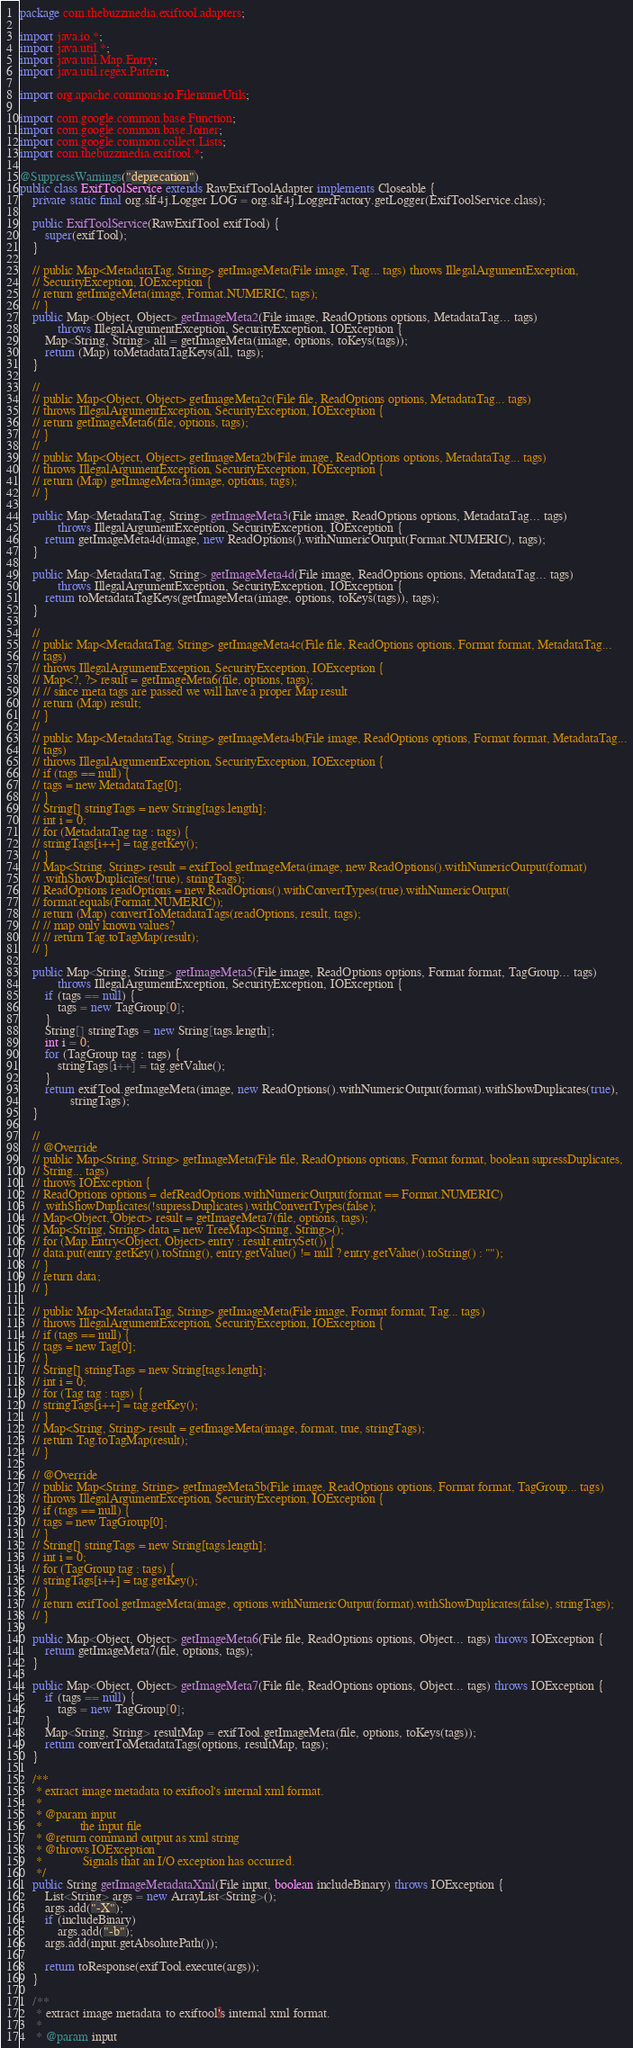<code> <loc_0><loc_0><loc_500><loc_500><_Java_>package com.thebuzzmedia.exiftool.adapters;

import java.io.*;
import java.util.*;
import java.util.Map.Entry;
import java.util.regex.Pattern;

import org.apache.commons.io.FilenameUtils;

import com.google.common.base.Function;
import com.google.common.base.Joiner;
import com.google.common.collect.Lists;
import com.thebuzzmedia.exiftool.*;

@SuppressWarnings("deprecation")
public class ExifToolService extends RawExifToolAdapter implements Closeable {
	private static final org.slf4j.Logger LOG = org.slf4j.LoggerFactory.getLogger(ExifToolService.class);

	public ExifToolService(RawExifTool exifTool) {
		super(exifTool);
	}

	// public Map<MetadataTag, String> getImageMeta(File image, Tag... tags) throws IllegalArgumentException,
	// SecurityException, IOException {
	// return getImageMeta(image, Format.NUMERIC, tags);
	// }
	public Map<Object, Object> getImageMeta2(File image, ReadOptions options, MetadataTag... tags)
			throws IllegalArgumentException, SecurityException, IOException {
		Map<String, String> all = getImageMeta(image, options, toKeys(tags));
		return (Map) toMetadataTagKeys(all, tags);
	}

	//
	// public Map<Object, Object> getImageMeta2c(File file, ReadOptions options, MetadataTag... tags)
	// throws IllegalArgumentException, SecurityException, IOException {
	// return getImageMeta6(file, options, tags);
	// }
	//
	// public Map<Object, Object> getImageMeta2b(File image, ReadOptions options, MetadataTag... tags)
	// throws IllegalArgumentException, SecurityException, IOException {
	// return (Map) getImageMeta3(image, options, tags);
	// }

	public Map<MetadataTag, String> getImageMeta3(File image, ReadOptions options, MetadataTag... tags)
			throws IllegalArgumentException, SecurityException, IOException {
		return getImageMeta4d(image, new ReadOptions().withNumericOutput(Format.NUMERIC), tags);
	}

	public Map<MetadataTag, String> getImageMeta4d(File image, ReadOptions options, MetadataTag... tags)
			throws IllegalArgumentException, SecurityException, IOException {
		return toMetadataTagKeys(getImageMeta(image, options, toKeys(tags)), tags);
	}

	//
	// public Map<MetadataTag, String> getImageMeta4c(File file, ReadOptions options, Format format, MetadataTag...
	// tags)
	// throws IllegalArgumentException, SecurityException, IOException {
	// Map<?, ?> result = getImageMeta6(file, options, tags);
	// // since meta tags are passed we will have a proper Map result
	// return (Map) result;
	// }
	//
	// public Map<MetadataTag, String> getImageMeta4b(File image, ReadOptions options, Format format, MetadataTag...
	// tags)
	// throws IllegalArgumentException, SecurityException, IOException {
	// if (tags == null) {
	// tags = new MetadataTag[0];
	// }
	// String[] stringTags = new String[tags.length];
	// int i = 0;
	// for (MetadataTag tag : tags) {
	// stringTags[i++] = tag.getKey();
	// }
	// Map<String, String> result = exifTool.getImageMeta(image, new ReadOptions().withNumericOutput(format)
	// .withShowDuplicates(!true), stringTags);
	// ReadOptions readOptions = new ReadOptions().withConvertTypes(true).withNumericOutput(
	// format.equals(Format.NUMERIC));
	// return (Map) convertToMetadataTags(readOptions, result, tags);
	// // map only known values?
	// // return Tag.toTagMap(result);
	// }

	public Map<String, String> getImageMeta5(File image, ReadOptions options, Format format, TagGroup... tags)
			throws IllegalArgumentException, SecurityException, IOException {
		if (tags == null) {
			tags = new TagGroup[0];
		}
		String[] stringTags = new String[tags.length];
		int i = 0;
		for (TagGroup tag : tags) {
			stringTags[i++] = tag.getValue();
		}
		return exifTool.getImageMeta(image, new ReadOptions().withNumericOutput(format).withShowDuplicates(true),
				stringTags);
	}

	//
	// @Override
	// public Map<String, String> getImageMeta(File file, ReadOptions options, Format format, boolean supressDuplicates,
	// String... tags)
	// throws IOException {
	// ReadOptions options = defReadOptions.withNumericOutput(format == Format.NUMERIC)
	// .withShowDuplicates(!supressDuplicates).withConvertTypes(false);
	// Map<Object, Object> result = getImageMeta7(file, options, tags);
	// Map<String, String> data = new TreeMap<String, String>();
	// for (Map.Entry<Object, Object> entry : result.entrySet()) {
	// data.put(entry.getKey().toString(), entry.getValue() != null ? entry.getValue().toString() : "");
	// }
	// return data;
	// }

	// public Map<MetadataTag, String> getImageMeta(File image, Format format, Tag... tags)
	// throws IllegalArgumentException, SecurityException, IOException {
	// if (tags == null) {
	// tags = new Tag[0];
	// }
	// String[] stringTags = new String[tags.length];
	// int i = 0;
	// for (Tag tag : tags) {
	// stringTags[i++] = tag.getKey();
	// }
	// Map<String, String> result = getImageMeta(image, format, true, stringTags);
	// return Tag.toTagMap(result);
	// }

	// @Override
	// public Map<String, String> getImageMeta5b(File image, ReadOptions options, Format format, TagGroup... tags)
	// throws IllegalArgumentException, SecurityException, IOException {
	// if (tags == null) {
	// tags = new TagGroup[0];
	// }
	// String[] stringTags = new String[tags.length];
	// int i = 0;
	// for (TagGroup tag : tags) {
	// stringTags[i++] = tag.getKey();
	// }
	// return exifTool.getImageMeta(image, options.withNumericOutput(format).withShowDuplicates(false), stringTags);
	// }

	public Map<Object, Object> getImageMeta6(File file, ReadOptions options, Object... tags) throws IOException {
		return getImageMeta7(file, options, tags);
	}

	public Map<Object, Object> getImageMeta7(File file, ReadOptions options, Object... tags) throws IOException {
		if (tags == null) {
			tags = new TagGroup[0];
		}
		Map<String, String> resultMap = exifTool.getImageMeta(file, options, toKeys(tags));
		return convertToMetadataTags(options, resultMap, tags);
	}

	/**
	 * extract image metadata to exiftool's internal xml format.
	 * 
	 * @param input
	 *            the input file
	 * @return command output as xml string
	 * @throws IOException
	 *             Signals that an I/O exception has occurred.
	 */
	public String getImageMetadataXml(File input, boolean includeBinary) throws IOException {
		List<String> args = new ArrayList<String>();
		args.add("-X");
		if (includeBinary)
			args.add("-b");
		args.add(input.getAbsolutePath());

		return toResponse(exifTool.execute(args));
	}

	/**
	 * extract image metadata to exiftool's internal xml format.
	 * 
	 * @param input</code> 